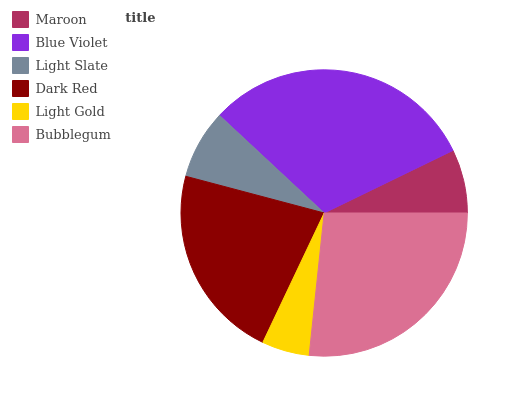Is Light Gold the minimum?
Answer yes or no. Yes. Is Blue Violet the maximum?
Answer yes or no. Yes. Is Light Slate the minimum?
Answer yes or no. No. Is Light Slate the maximum?
Answer yes or no. No. Is Blue Violet greater than Light Slate?
Answer yes or no. Yes. Is Light Slate less than Blue Violet?
Answer yes or no. Yes. Is Light Slate greater than Blue Violet?
Answer yes or no. No. Is Blue Violet less than Light Slate?
Answer yes or no. No. Is Dark Red the high median?
Answer yes or no. Yes. Is Light Slate the low median?
Answer yes or no. Yes. Is Maroon the high median?
Answer yes or no. No. Is Light Gold the low median?
Answer yes or no. No. 